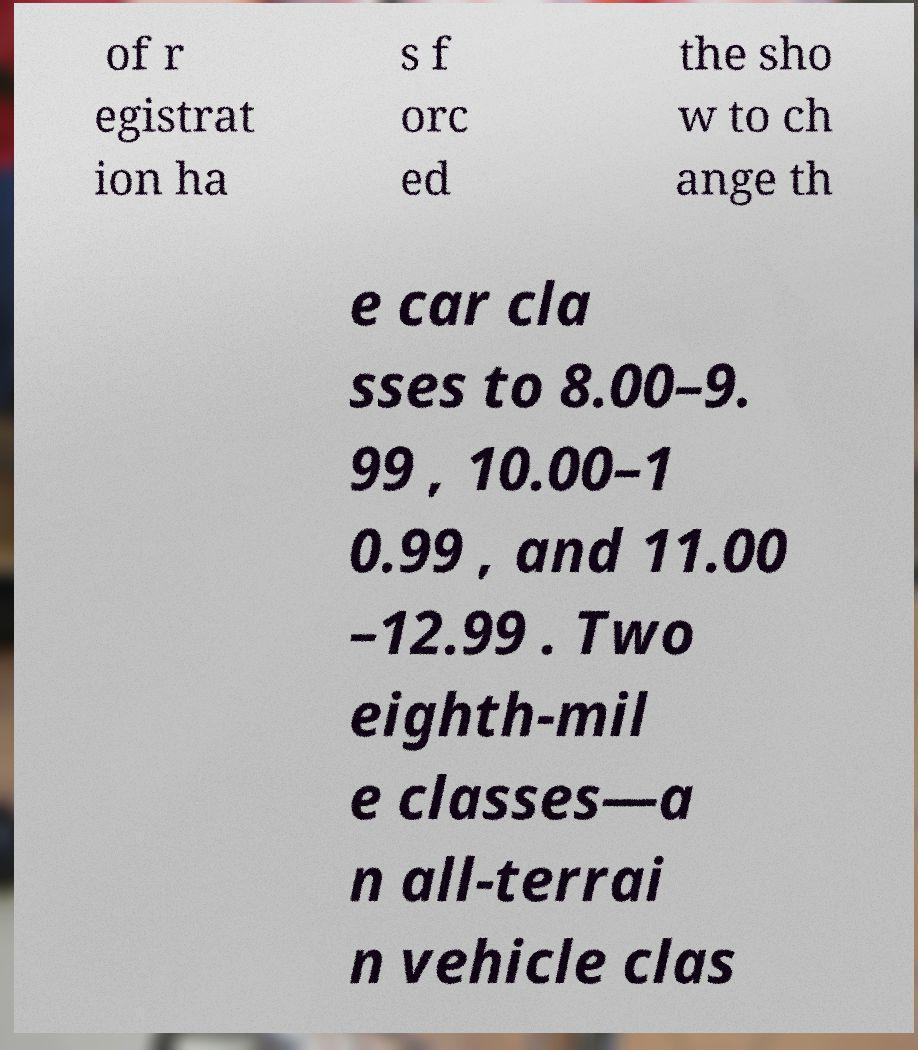What messages or text are displayed in this image? I need them in a readable, typed format. of r egistrat ion ha s f orc ed the sho w to ch ange th e car cla sses to 8.00–9. 99 , 10.00–1 0.99 , and 11.00 –12.99 . Two eighth-mil e classes—a n all-terrai n vehicle clas 